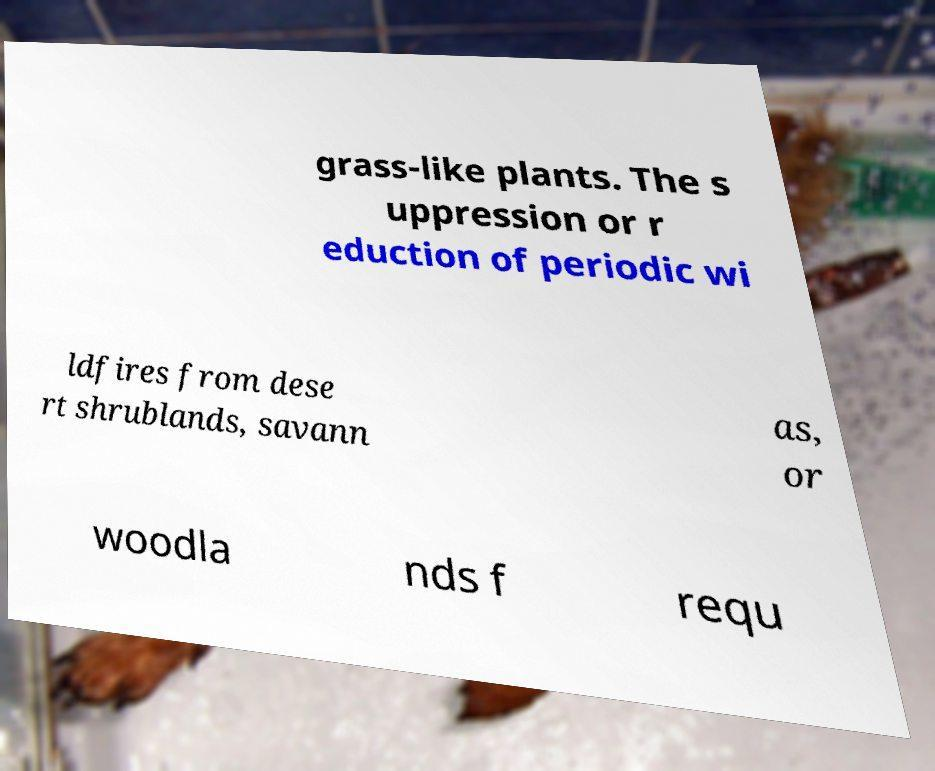Please read and relay the text visible in this image. What does it say? grass-like plants. The s uppression or r eduction of periodic wi ldfires from dese rt shrublands, savann as, or woodla nds f requ 